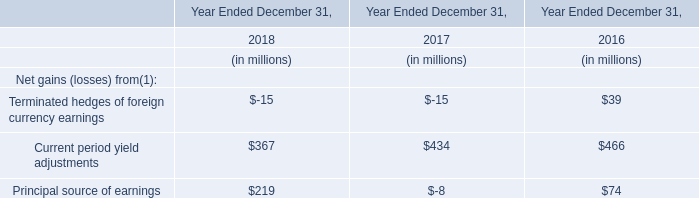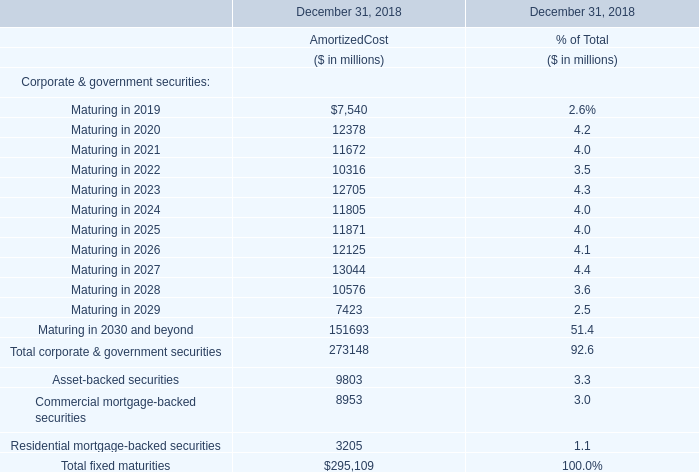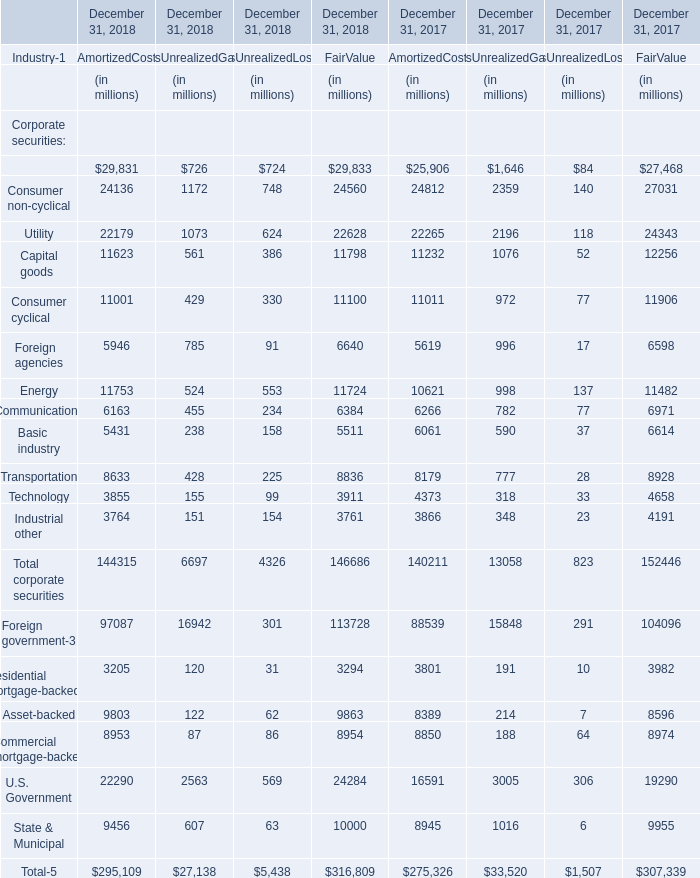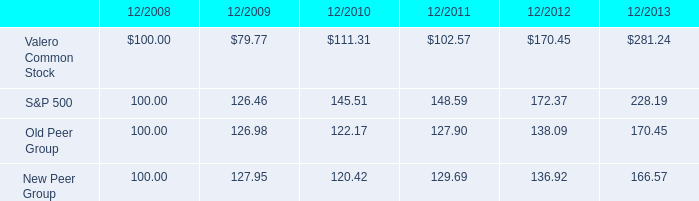In the year with the greatest proportion of AmortizedCost, what is the proportion of AmortizedCostto the tatal? 
Answer: 4.4. 